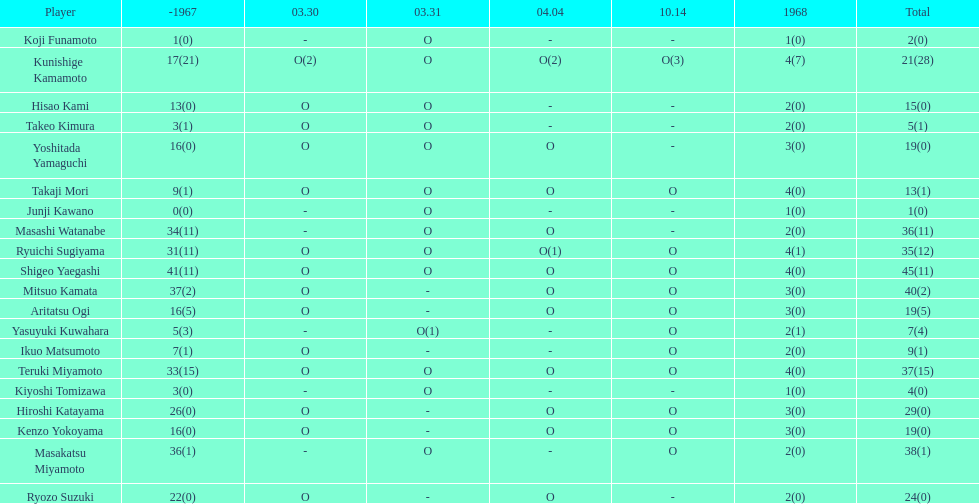How many total did mitsuo kamata have? 40(2). 